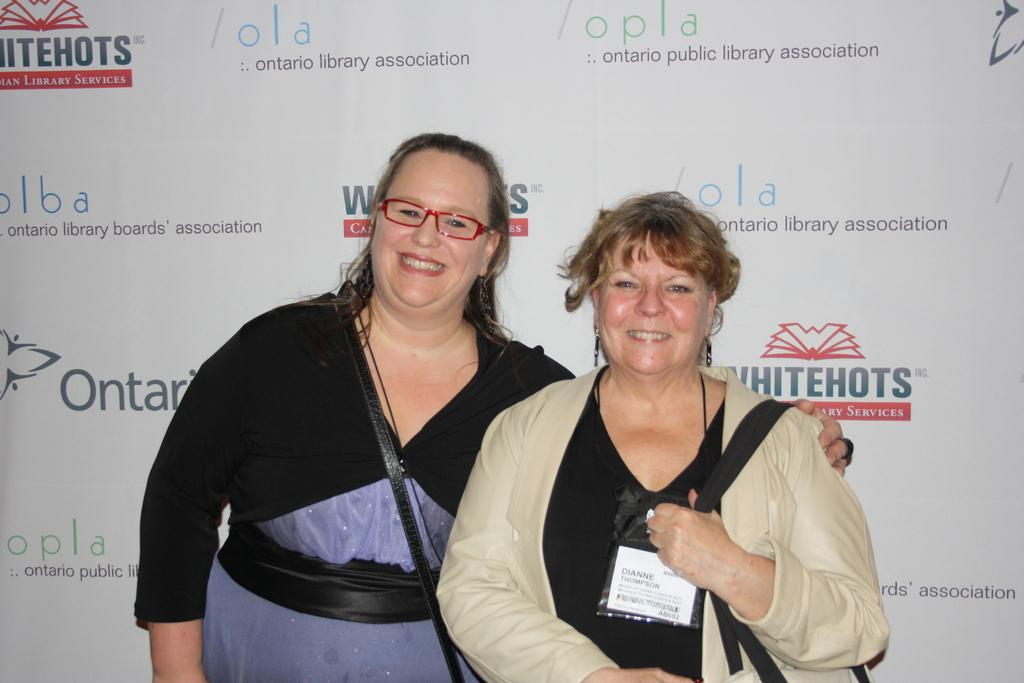How many women are present in the image? There are two women standing in the image. What is the facial expression of the women? Both women are smiling. Can you describe the appearance of the woman on the left side? The woman on the left side is wearing spectacles. What can be seen in the background of the image? There are logos and text visible in the background of the image. What type of poison is the woman on the right side holding in the image? There is no poison present in the image; both women are smiling and there are no dangerous substances visible. 